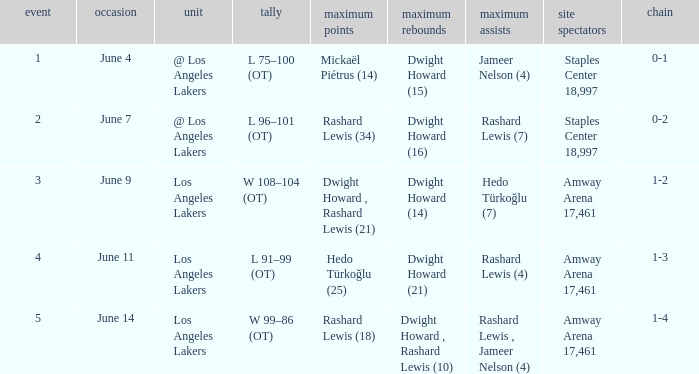What is the highest Game, when High Assists is "Hedo Türkoğlu (7)"? 3.0. 